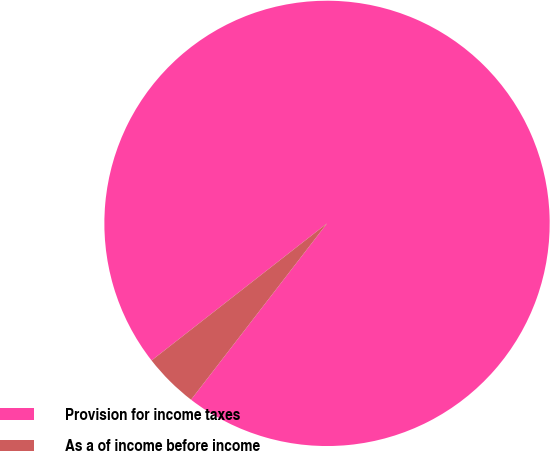Convert chart. <chart><loc_0><loc_0><loc_500><loc_500><pie_chart><fcel>Provision for income taxes<fcel>As a of income before income<nl><fcel>96.01%<fcel>3.99%<nl></chart> 